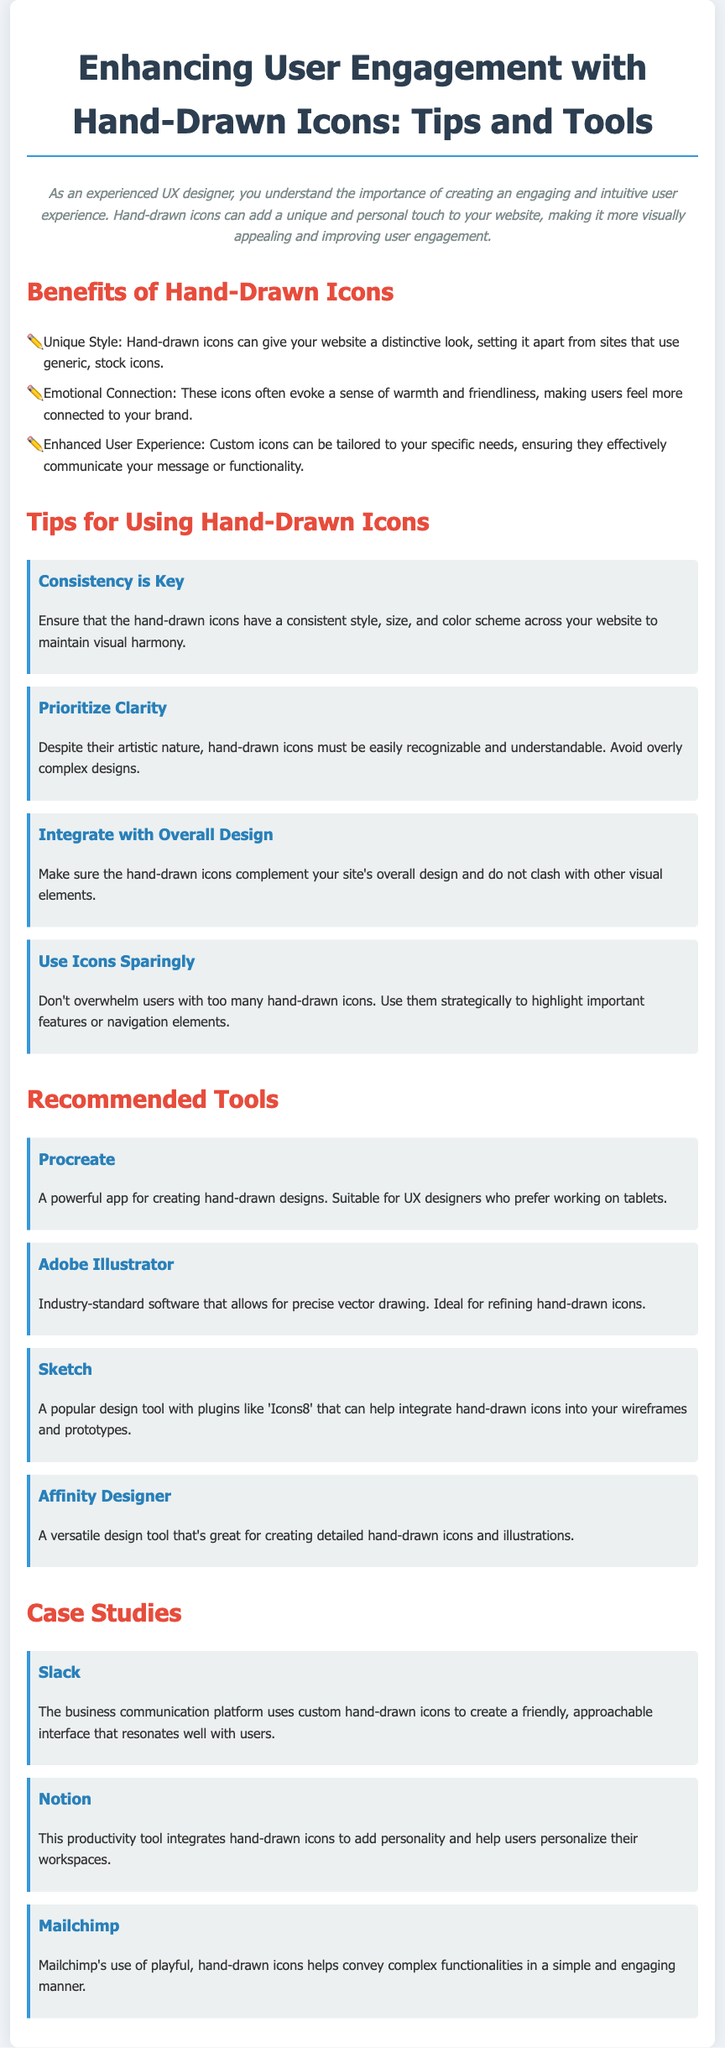What are the benefits of hand-drawn icons? The document lists three benefits of hand-drawn icons, which are: Unique Style, Emotional Connection, and Enhanced User Experience.
Answer: Unique Style, Emotional Connection, Enhanced User Experience What is the first tip for using hand-drawn icons? The tips section provides various tips, with the first being about consistency in style across the website.
Answer: Consistency is Key Which tool is described as a powerful app for creating hand-drawn designs? The document outlines several tools, and Procreate is highlighted as a powerful app for this purpose.
Answer: Procreate How many case studies are provided in the document? There are three case studies mentioned in the case studies section.
Answer: Three What is the main purpose of using hand-drawn icons according to the document? The introduction highlights the goal of enhancing user engagement by making the website more visually appealing.
Answer: Enhancing user engagement What should be prioritized according to the second tip for using hand-drawn icons? The second tip emphasizes the importance of clarity in the design of hand-drawn icons.
Answer: Clarity 